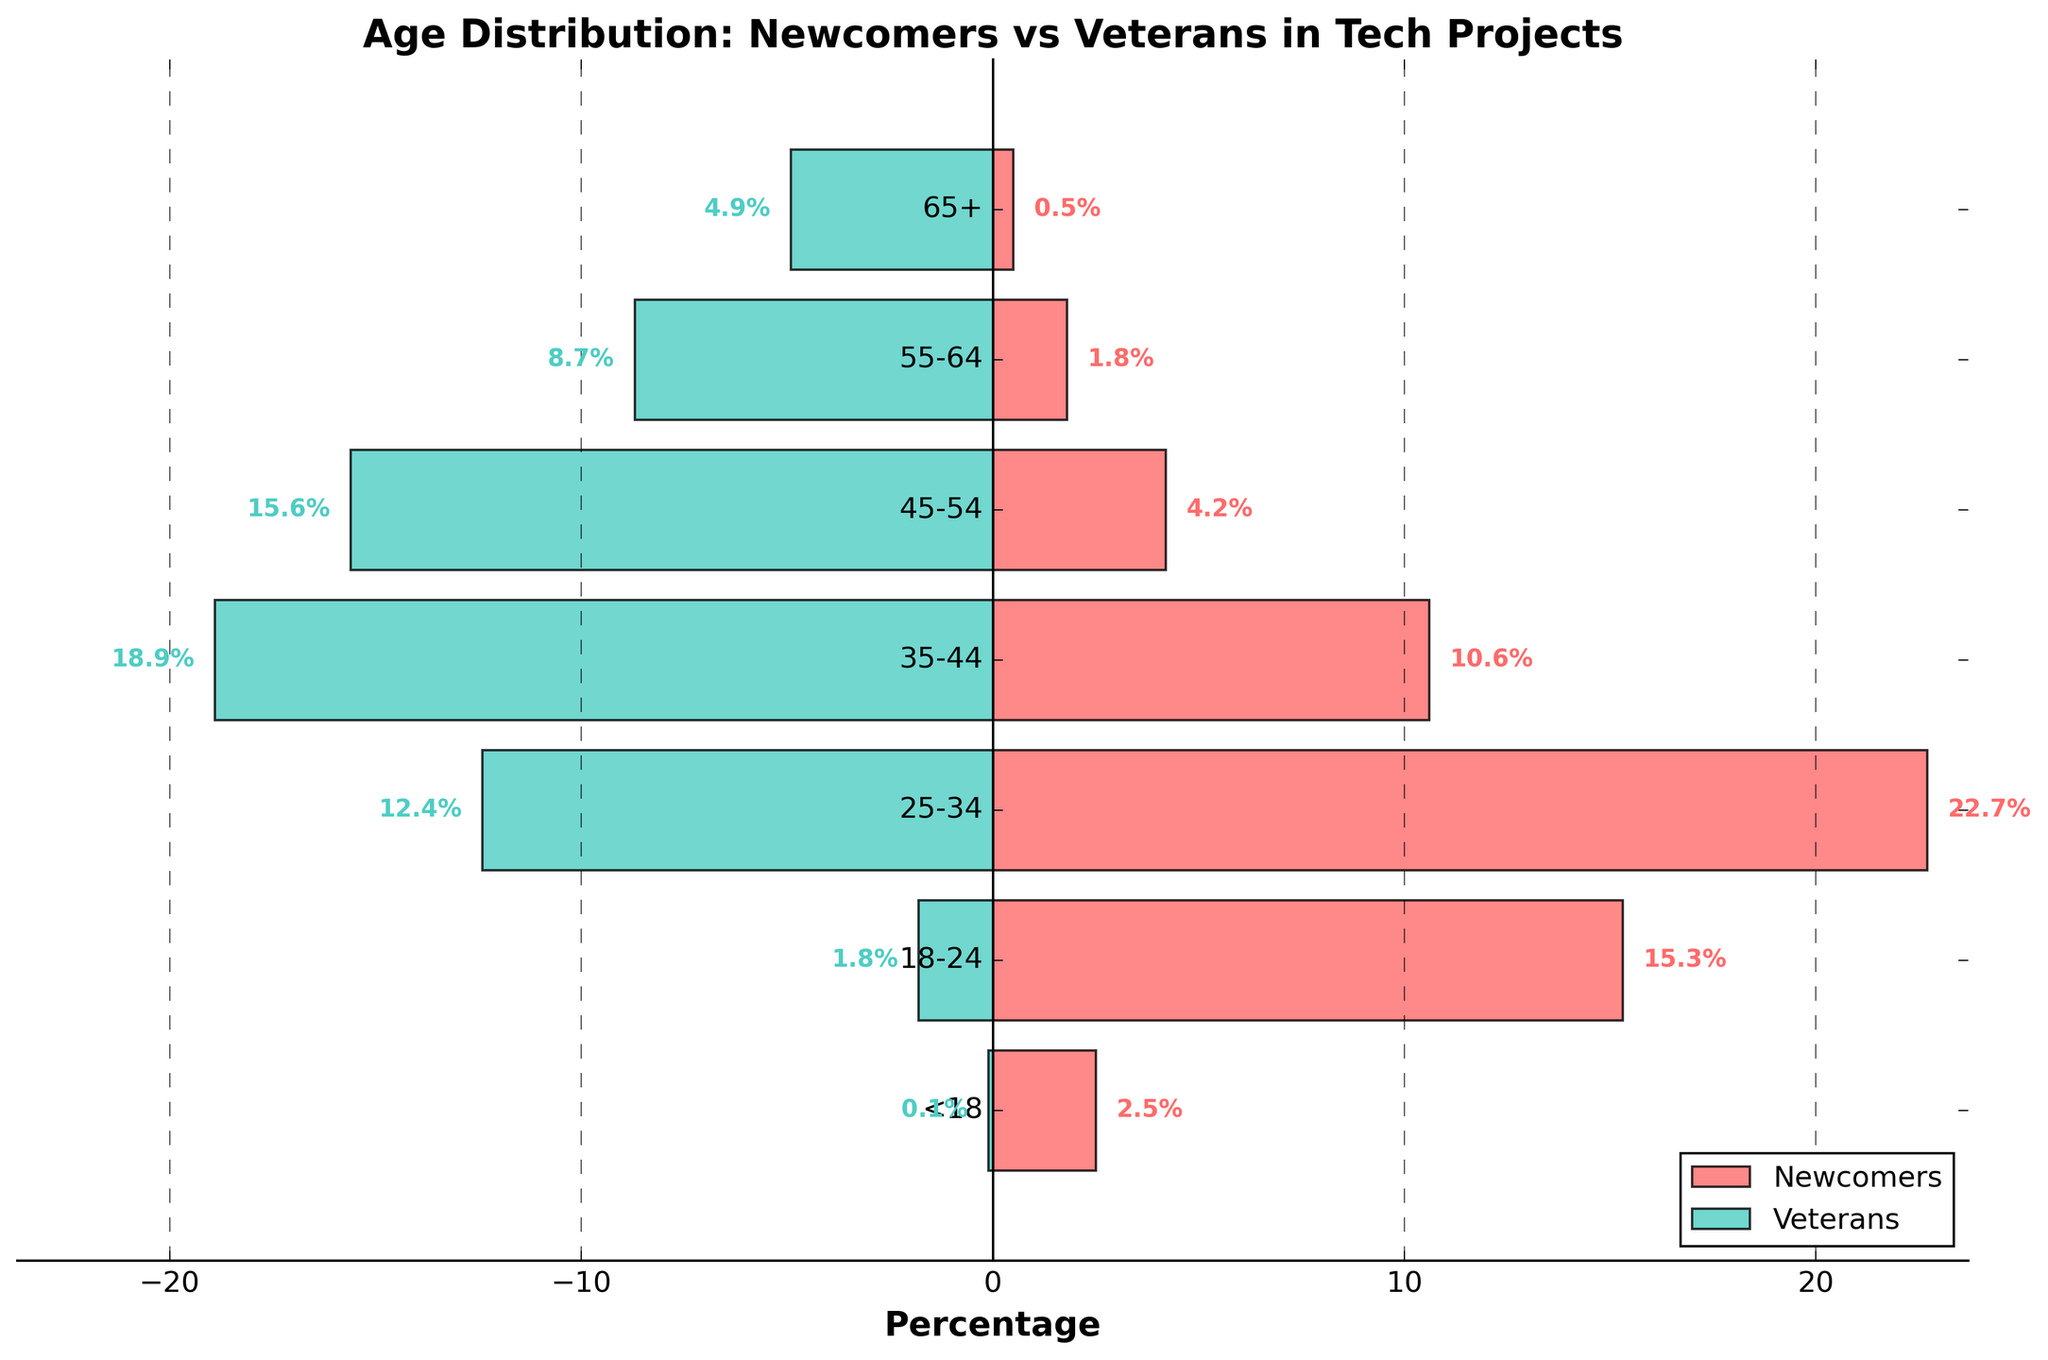What is the age range with the highest percentage of newcomers? The figure shows newcomers in red bars on the right side. The longest red bar corresponds to the 25-34 age range. Therefore, this age range has the highest percentage of newcomers.
Answer: 25-34 Which age range has the highest percentage of veterans? The left-side bars represent veterans in green. The longest green bar is for the 35-44 age range, indicating that it has the highest percentage of veterans.
Answer: 35-44 What is the percentage difference between newcomers and veterans in the 18-24 age range? For the 18-24 age range, newcomers are at 15.3%, and veterans are at 1.8%. The difference is calculated by subtracting the smaller percentage from the larger percentage: 15.3% - 1.8% = 13.5%.
Answer: 13.5% How many age ranges have a higher percentage of veterans than newcomers? By comparing the green and red bars in each age range, we can see that the ranges 35-44, 45-54, 55-64, and 65+ have higher percentages of veterans compared to newcomers. There are 4 such age ranges.
Answer: 4 Which age range shows the smallest representation for newcomers? The smallest red bar on the right side indicates the newcomers under the '<18' age range, which has a percentage of 2.5%.
Answer: <18 For the 45-54 age group, what is the combined percentage of newcomers and veterans? The 45-54 age group has 4.2% newcomers and 15.6% veterans. Adding these percentages gives 4.2% + 15.6% = 19.8%.
Answer: 19.8% In which age range is the disparity between newcomers and veterans the greatest? To find the greatest disparity, we examine the absolute difference in percentages between newcomers and veterans for each age range. The 18-24 age range has the highest difference: 15.3% (newcomers) - 1.8% (veterans) = 13.5%. This is the largest disparity.
Answer: 18-24 What is the total percentage of contributors (newcomers and veterans) in the 55-64 age group? The 55-64 age group has 1.8% newcomers and 8.7% veterans. The total percentage is 1.8% + 8.7% = 10.5%.
Answer: 10.5% How do the percentages of newcomers compare between the age ranges 25-34 and 35-44? The percentage of newcomers for 25-34 is 22.7%, whereas for 35-44, it is 10.6%. Comparing these figures, we see that the 25-34 age range has a higher percentage of newcomers.
Answer: 25-34 has a higher percentage 